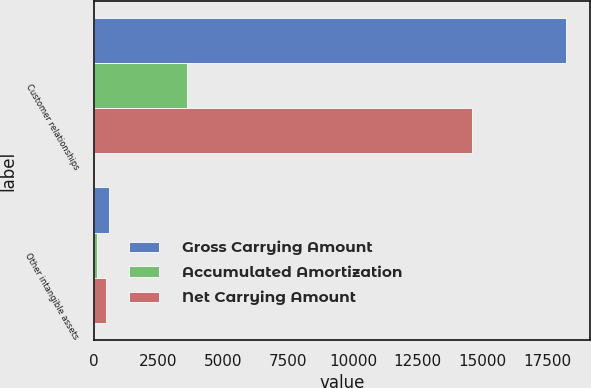<chart> <loc_0><loc_0><loc_500><loc_500><stacked_bar_chart><ecel><fcel>Customer relationships<fcel>Other intangible assets<nl><fcel>Gross Carrying Amount<fcel>18226<fcel>615<nl><fcel>Accumulated Amortization<fcel>3618<fcel>128<nl><fcel>Net Carrying Amount<fcel>14608<fcel>487<nl></chart> 